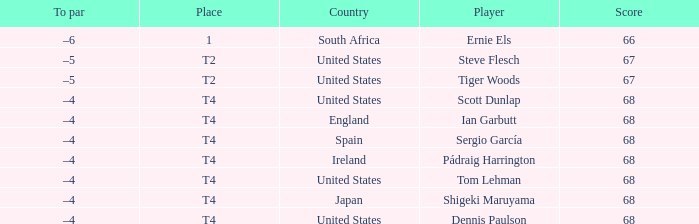What is T2 Place Player Steve Flesch's Score? 67.0. 